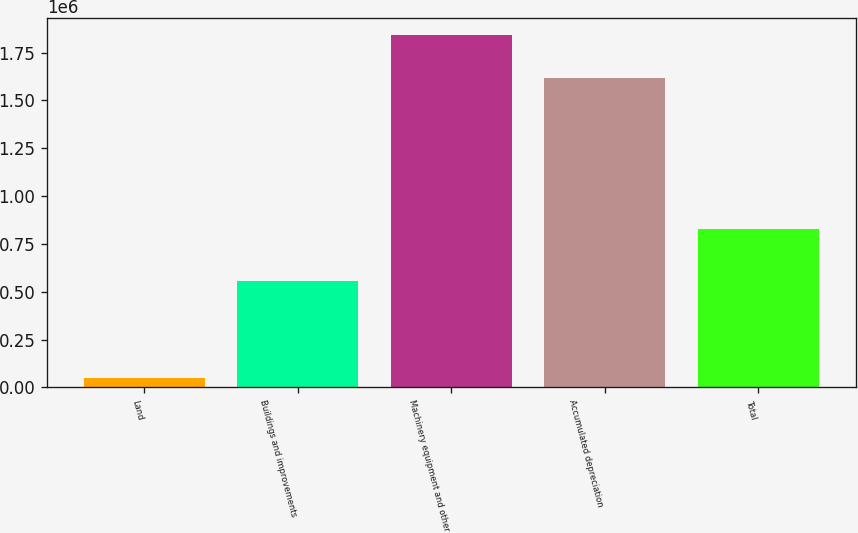Convert chart to OTSL. <chart><loc_0><loc_0><loc_500><loc_500><bar_chart><fcel>Land<fcel>Buildings and improvements<fcel>Machinery equipment and other<fcel>Accumulated depreciation<fcel>Total<nl><fcel>48010<fcel>555262<fcel>1.84064e+06<fcel>1.61499e+06<fcel>828922<nl></chart> 